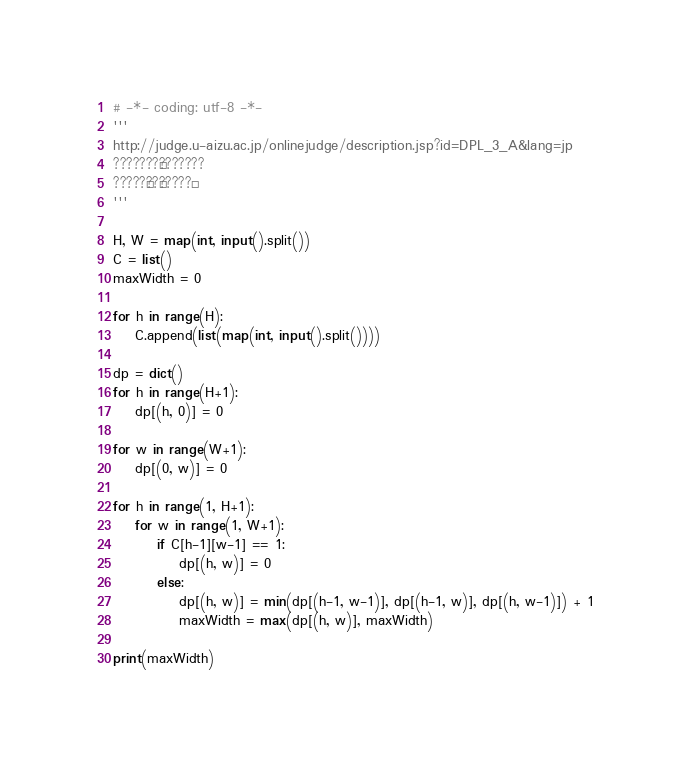Convert code to text. <code><loc_0><loc_0><loc_500><loc_500><_Python_># -*- coding: utf-8 -*-
'''
http://judge.u-aizu.ac.jp/onlinejudge/description.jsp?id=DPL_3_A&lang=jp
???????¨???????
?????§??£?????¢
'''

H, W = map(int, input().split())
C = list()
maxWidth = 0

for h in range(H):
    C.append(list(map(int, input().split())))

dp = dict()
for h in range(H+1):
    dp[(h, 0)] = 0

for w in range(W+1):
    dp[(0, w)] = 0

for h in range(1, H+1):
    for w in range(1, W+1):
        if C[h-1][w-1] == 1:
            dp[(h, w)] = 0
        else:
            dp[(h, w)] = min(dp[(h-1, w-1)], dp[(h-1, w)], dp[(h, w-1)]) + 1
            maxWidth = max(dp[(h, w)], maxWidth)

print(maxWidth)</code> 